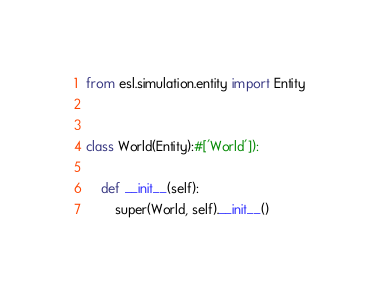Convert code to text. <code><loc_0><loc_0><loc_500><loc_500><_Python_>

from esl.simulation.entity import Entity


class World(Entity):#['World']):
    
    def __init__(self):
        super(World, self).__init__()
</code> 